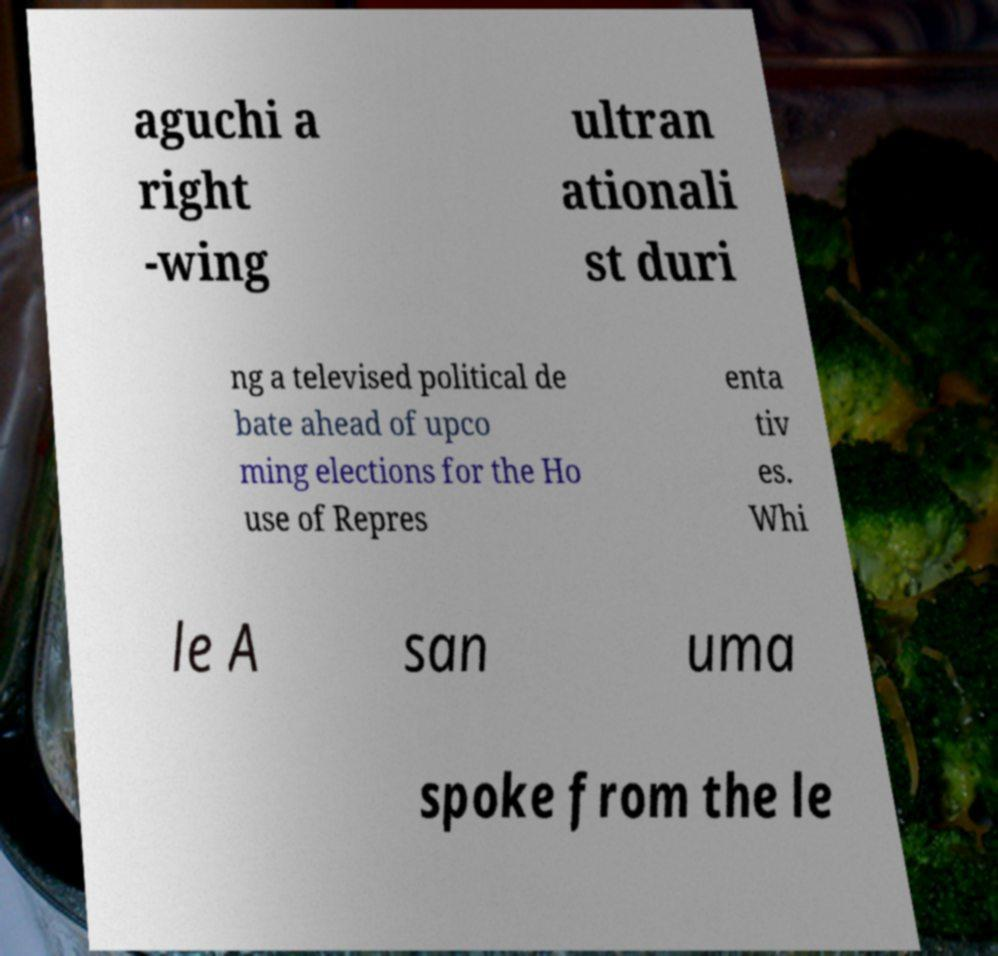Can you accurately transcribe the text from the provided image for me? aguchi a right -wing ultran ationali st duri ng a televised political de bate ahead of upco ming elections for the Ho use of Repres enta tiv es. Whi le A san uma spoke from the le 